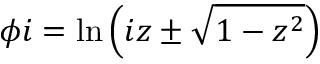<formula> <loc_0><loc_0><loc_500><loc_500>\phi i = \ln \left ( i z \pm { \sqrt { 1 - z ^ { 2 } } } \right )</formula> 